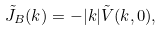<formula> <loc_0><loc_0><loc_500><loc_500>\tilde { J } _ { B } ( k ) = - | k | \tilde { V } ( k , 0 ) ,</formula> 